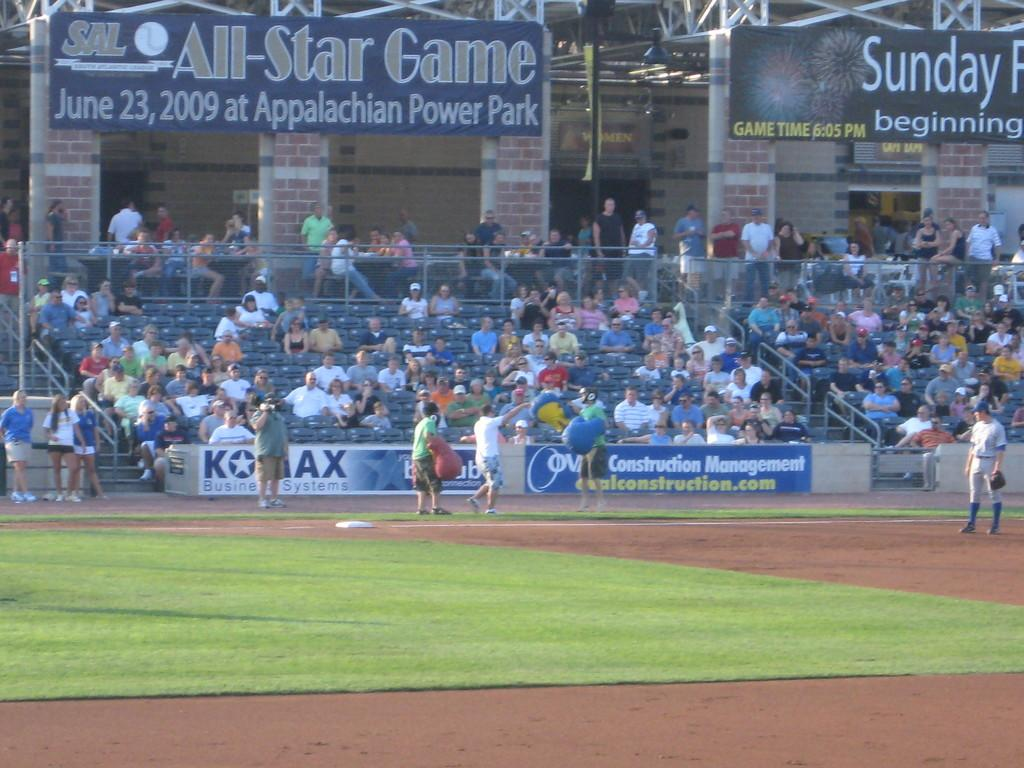<image>
Create a compact narrative representing the image presented. a baseball game that has an all star ad on it 